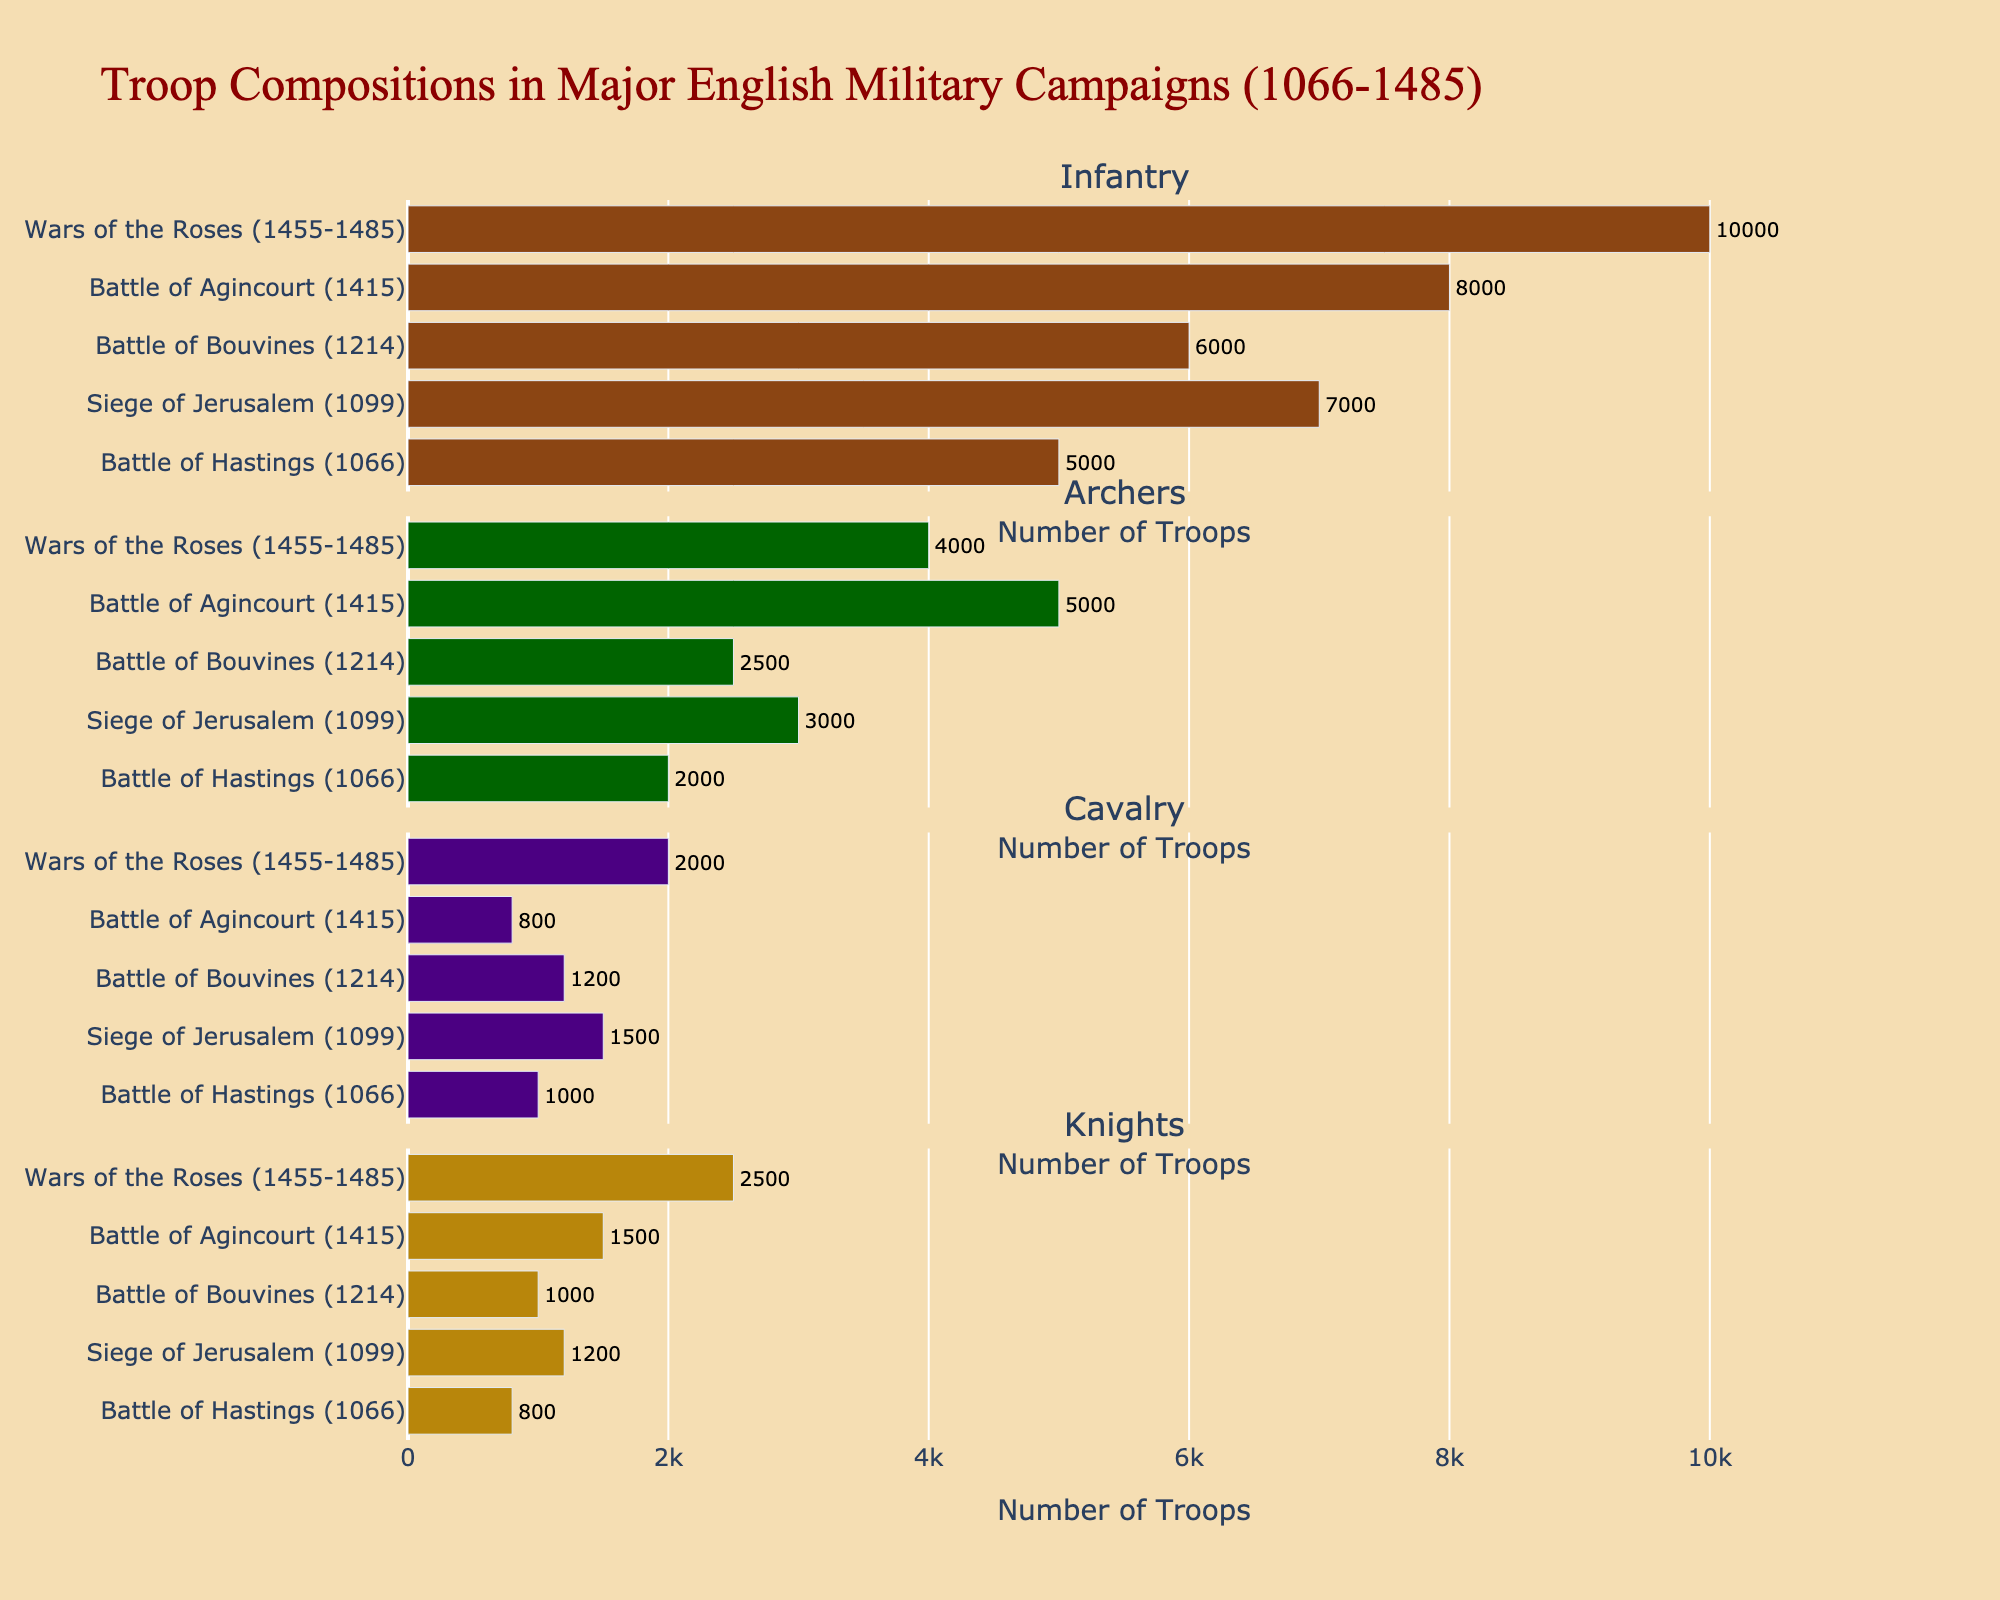what is the title of the figure? The title is usually the largest text displayed prominently at the top of the figure. In this case, it reads "Troop Compositions in Major English Military Campaigns (1066-1485)".
Answer: Troop Compositions in Major English Military Campaigns (1066-1485) How many subplots are there in the figure? Each troop type has its own subplot, so counting the number of different troop types (Infantry, Archers, Cavalry, Knights) gives us the number of subplots.
Answer: 4 Which military campaign had the highest number of Knights? By looking at the 'Knights' subplot, the longest horizontal bar represents the campaign with the highest number. The longest bar belongs to the "Wars of the Roses (1455-1485)".
Answer: Wars of the Roses (1455-1485) How does the number of Infantry in the Battle of Agincourt compare to the number of Infantry in the Siege of Jerusalem? Find the horizontal bars for 'Infantry' subplot for both campaigns. The number of Infantry in the Battle of Agincourt is 8000, which is higher than the 7000 in the Siege of Jerusalem.
Answer: Agincourt has more Infantry What is the combined total of Cavalry in all campaigns? Sum the number of Cavalry across all campaigns by adding up values from the 'Cavalry' subplot: 1000 + 1500 + 1200 + 800 + 2000. The total is 6500.
Answer: 6500 Which campaign had the lowest number of Archers? Looking at the 'Archers' subplot, the shortest horizontal bar indicates the lowest number, which corresponds to the Battle of Hastings (1066) with 2000 archers.
Answer: Battle of Hastings (1066) What is the average number of Knights across all campaigns? Sum the number of Knights across all campaigns: 800 + 1200 + 1000 + 1500 + 2500, which is 7000. Then divide this sum by the total number of campaigns (5). The average is 7000/5 = 1400.
Answer: 1400 Compare the number of Archers in the Battle of Agincourt to the Battle of Hastings. Looking at the 'Archers' subplot, the Battle of Agincourt has 5000 Archers, while the Battle of Hastings has 2000. Agincourt has more Archers.
Answer: Agincourt has more Archers Which troop type had the most significant variation in numbers across all campaigns? By examining each subplot, we notice the greatest difference in bar lengths. The 'Knights' subplot shows the most variation, ranging from 800 to 2500.
Answer: Knights 